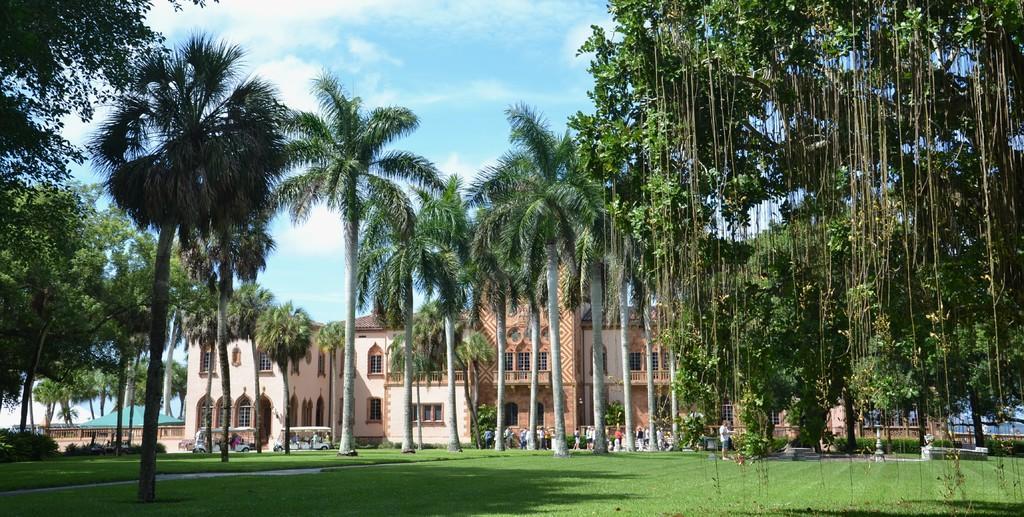In one or two sentences, can you explain what this image depicts? At the bottom of the picture, we see grass. In the middle of the picture, we see the man is standing. There are trees in the background. Beside that, we see many people are standing. On the left side, we see a building with a green color roof. Beside that, we see two vehicles. In the background, we see a building. At the top of the picture, we see the sky, which is blue in color. 